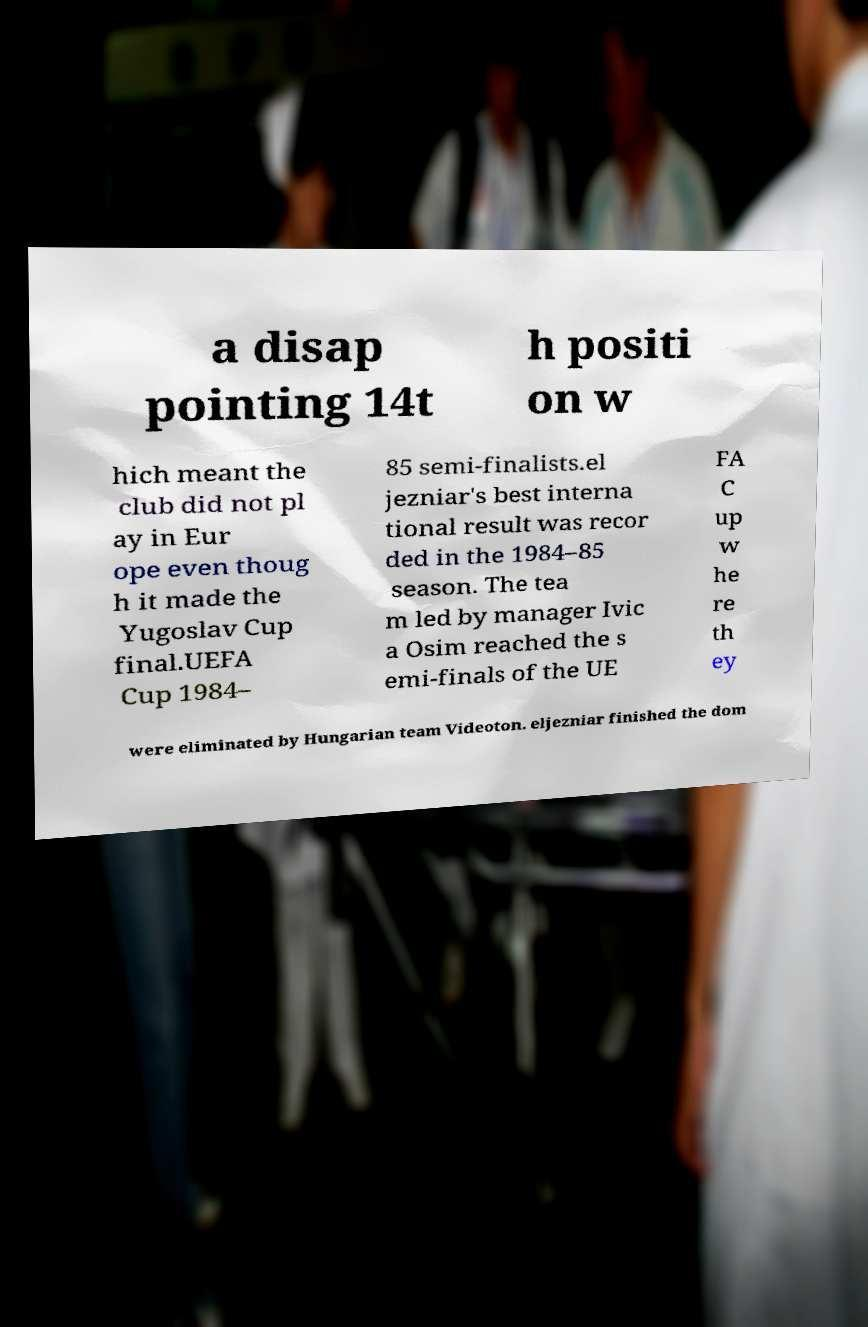What messages or text are displayed in this image? I need them in a readable, typed format. a disap pointing 14t h positi on w hich meant the club did not pl ay in Eur ope even thoug h it made the Yugoslav Cup final.UEFA Cup 1984– 85 semi-finalists.el jezniar's best interna tional result was recor ded in the 1984–85 season. The tea m led by manager Ivic a Osim reached the s emi-finals of the UE FA C up w he re th ey were eliminated by Hungarian team Videoton. eljezniar finished the dom 